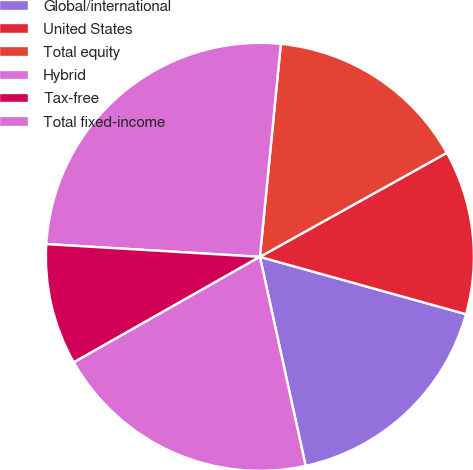Convert chart to OTSL. <chart><loc_0><loc_0><loc_500><loc_500><pie_chart><fcel>Global/international<fcel>United States<fcel>Total equity<fcel>Hybrid<fcel>Tax-free<fcel>Total fixed-income<nl><fcel>17.25%<fcel>12.4%<fcel>15.36%<fcel>25.61%<fcel>9.16%<fcel>20.22%<nl></chart> 